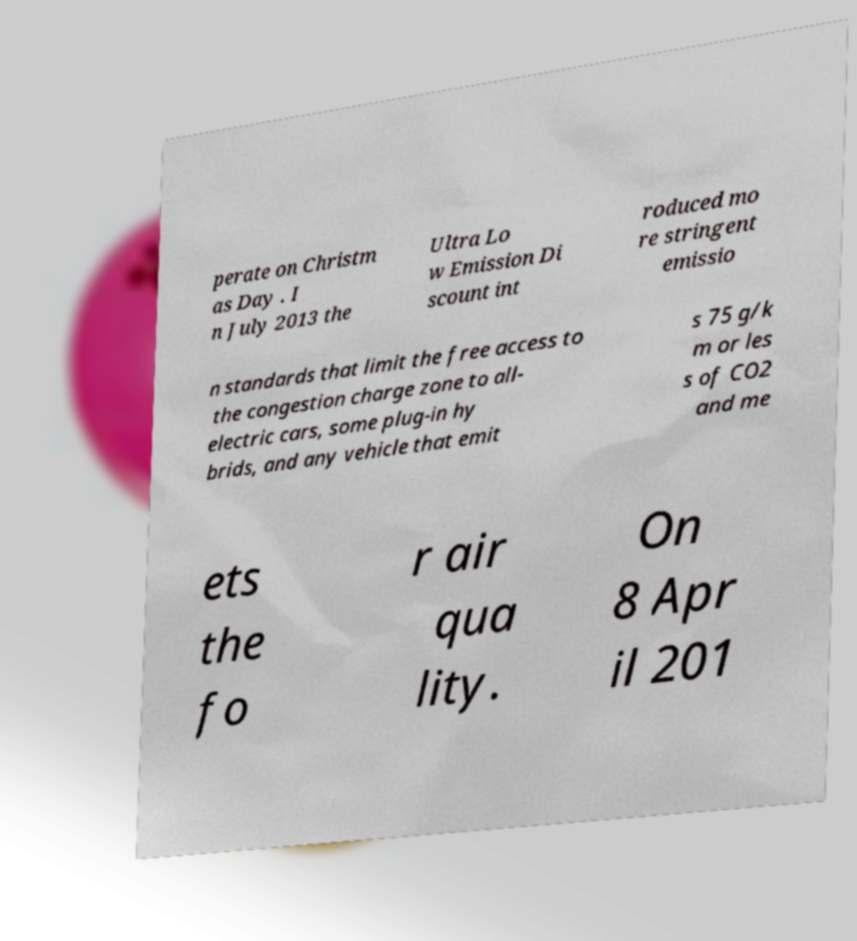Can you read and provide the text displayed in the image?This photo seems to have some interesting text. Can you extract and type it out for me? perate on Christm as Day . I n July 2013 the Ultra Lo w Emission Di scount int roduced mo re stringent emissio n standards that limit the free access to the congestion charge zone to all- electric cars, some plug-in hy brids, and any vehicle that emit s 75 g/k m or les s of CO2 and me ets the fo r air qua lity. On 8 Apr il 201 